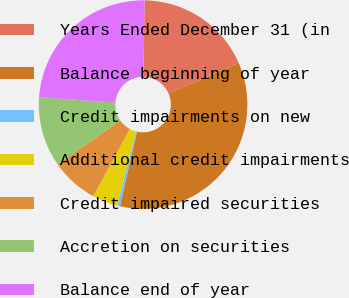<chart> <loc_0><loc_0><loc_500><loc_500><pie_chart><fcel>Years Ended December 31 (in<fcel>Balance beginning of year<fcel>Credit impairments on new<fcel>Additional credit impairments<fcel>Credit impaired securities<fcel>Accretion on securities<fcel>Balance end of year<nl><fcel>18.25%<fcel>35.09%<fcel>0.44%<fcel>3.91%<fcel>7.37%<fcel>10.84%<fcel>24.1%<nl></chart> 